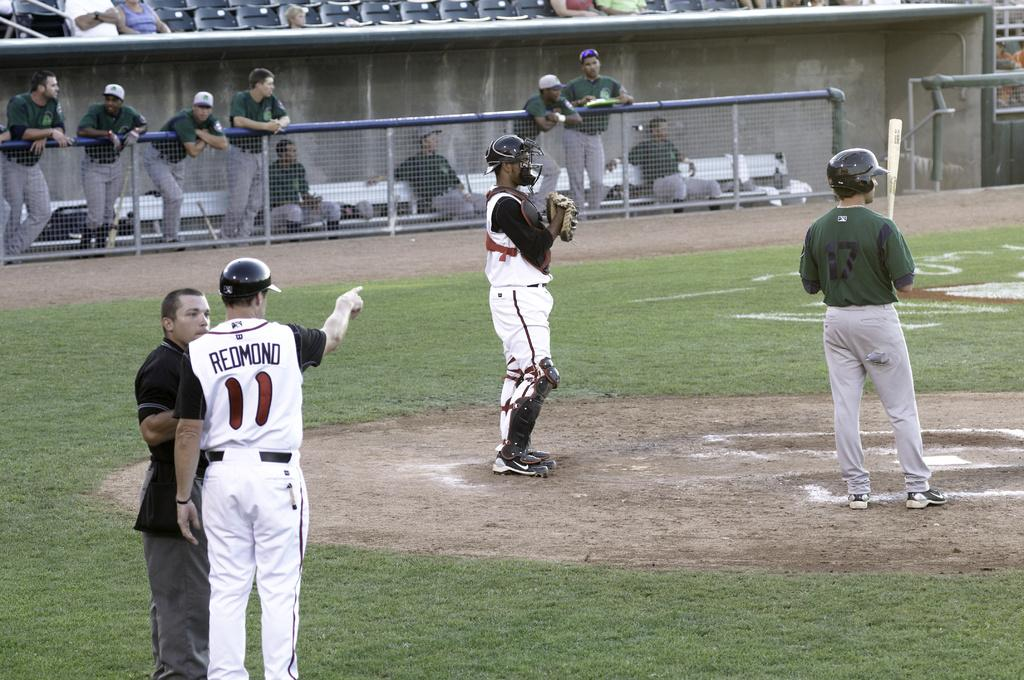<image>
Write a terse but informative summary of the picture. A baseball player wearing a black and white uniform with the name Redmond on the back talks to the umpire on the baseball field while other players watch. 